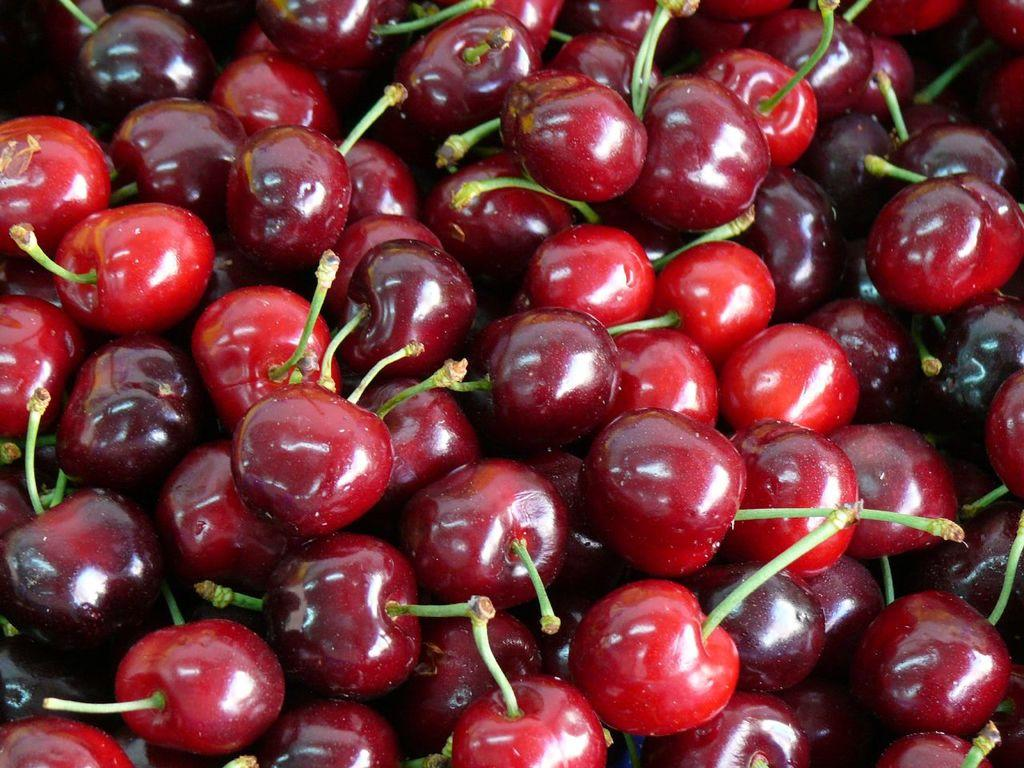What type of fruit is present in the image? There are cherries in the image. What type of expert is giving a lecture about trains in the image? There is no expert or lecture about trains present in the image; it only features cherries. 